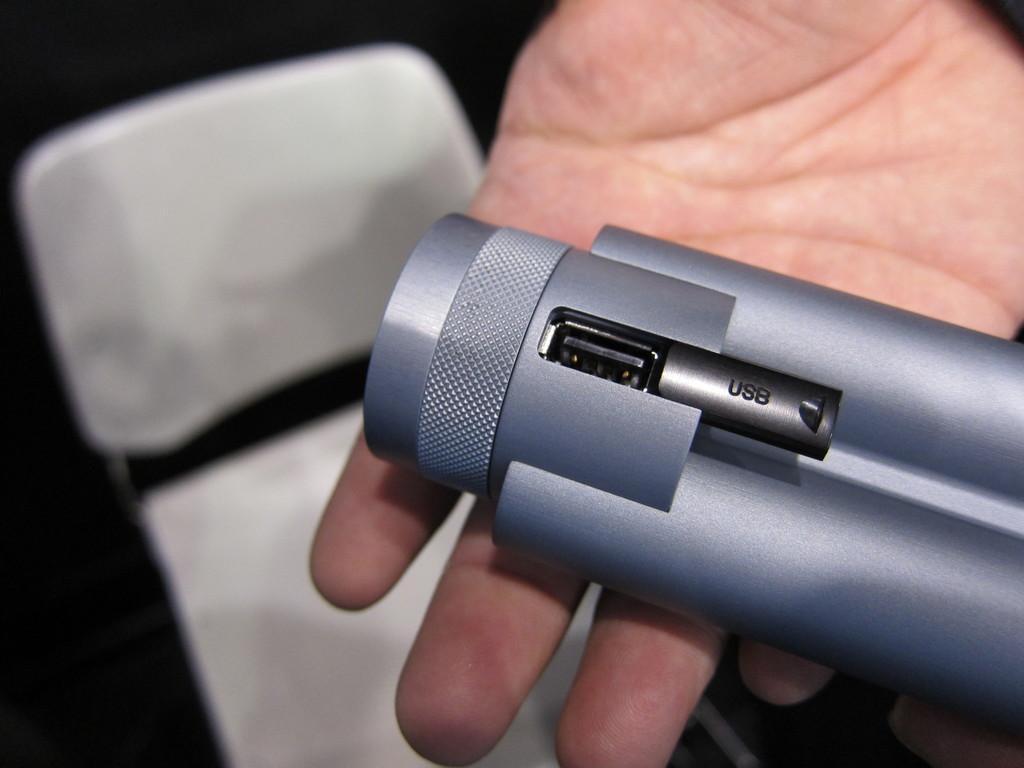Could you give a brief overview of what you see in this image? In this image there is an object in the hand of a person and there is a chair. 